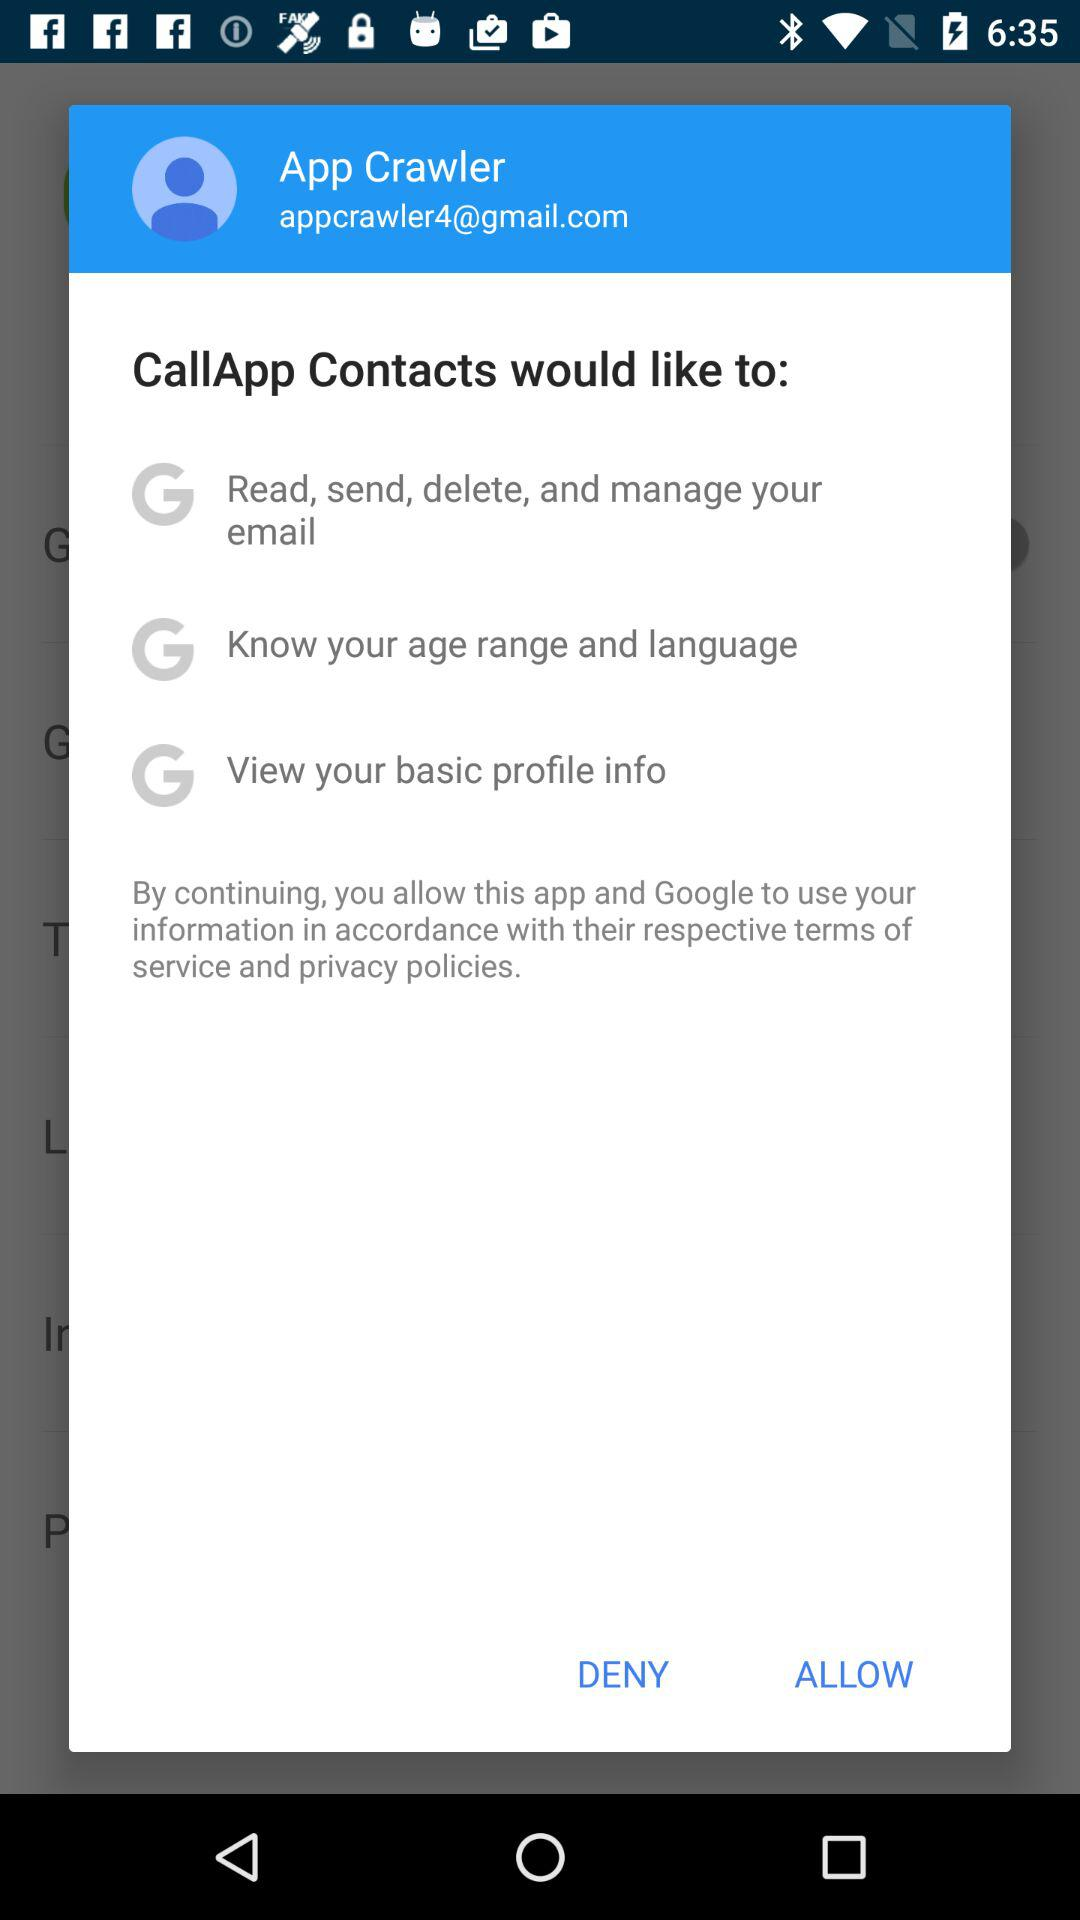What is the given email address? The given email address is appcrawler4@gmail.com. 